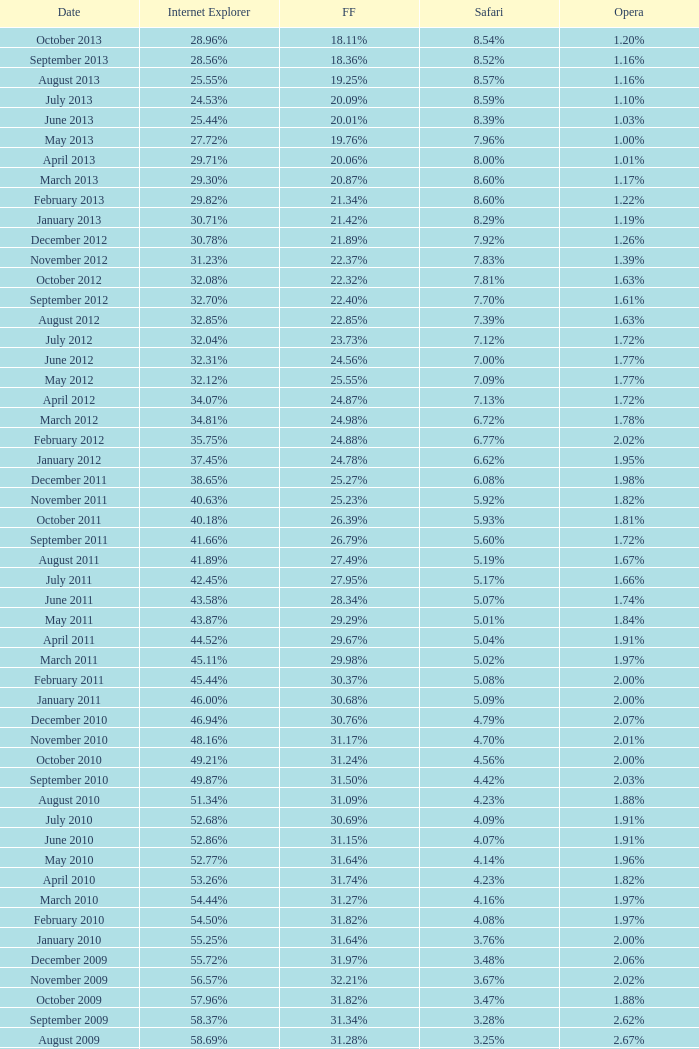What percentage of browsers were using Internet Explorer in April 2009? 61.88%. 